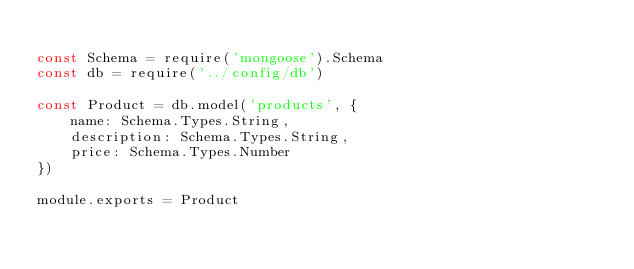<code> <loc_0><loc_0><loc_500><loc_500><_JavaScript_>
const Schema = require('mongoose').Schema
const db = require('../config/db')

const Product = db.model('products', {
    name: Schema.Types.String,
    description: Schema.Types.String,
    price: Schema.Types.Number
})

module.exports = Product</code> 